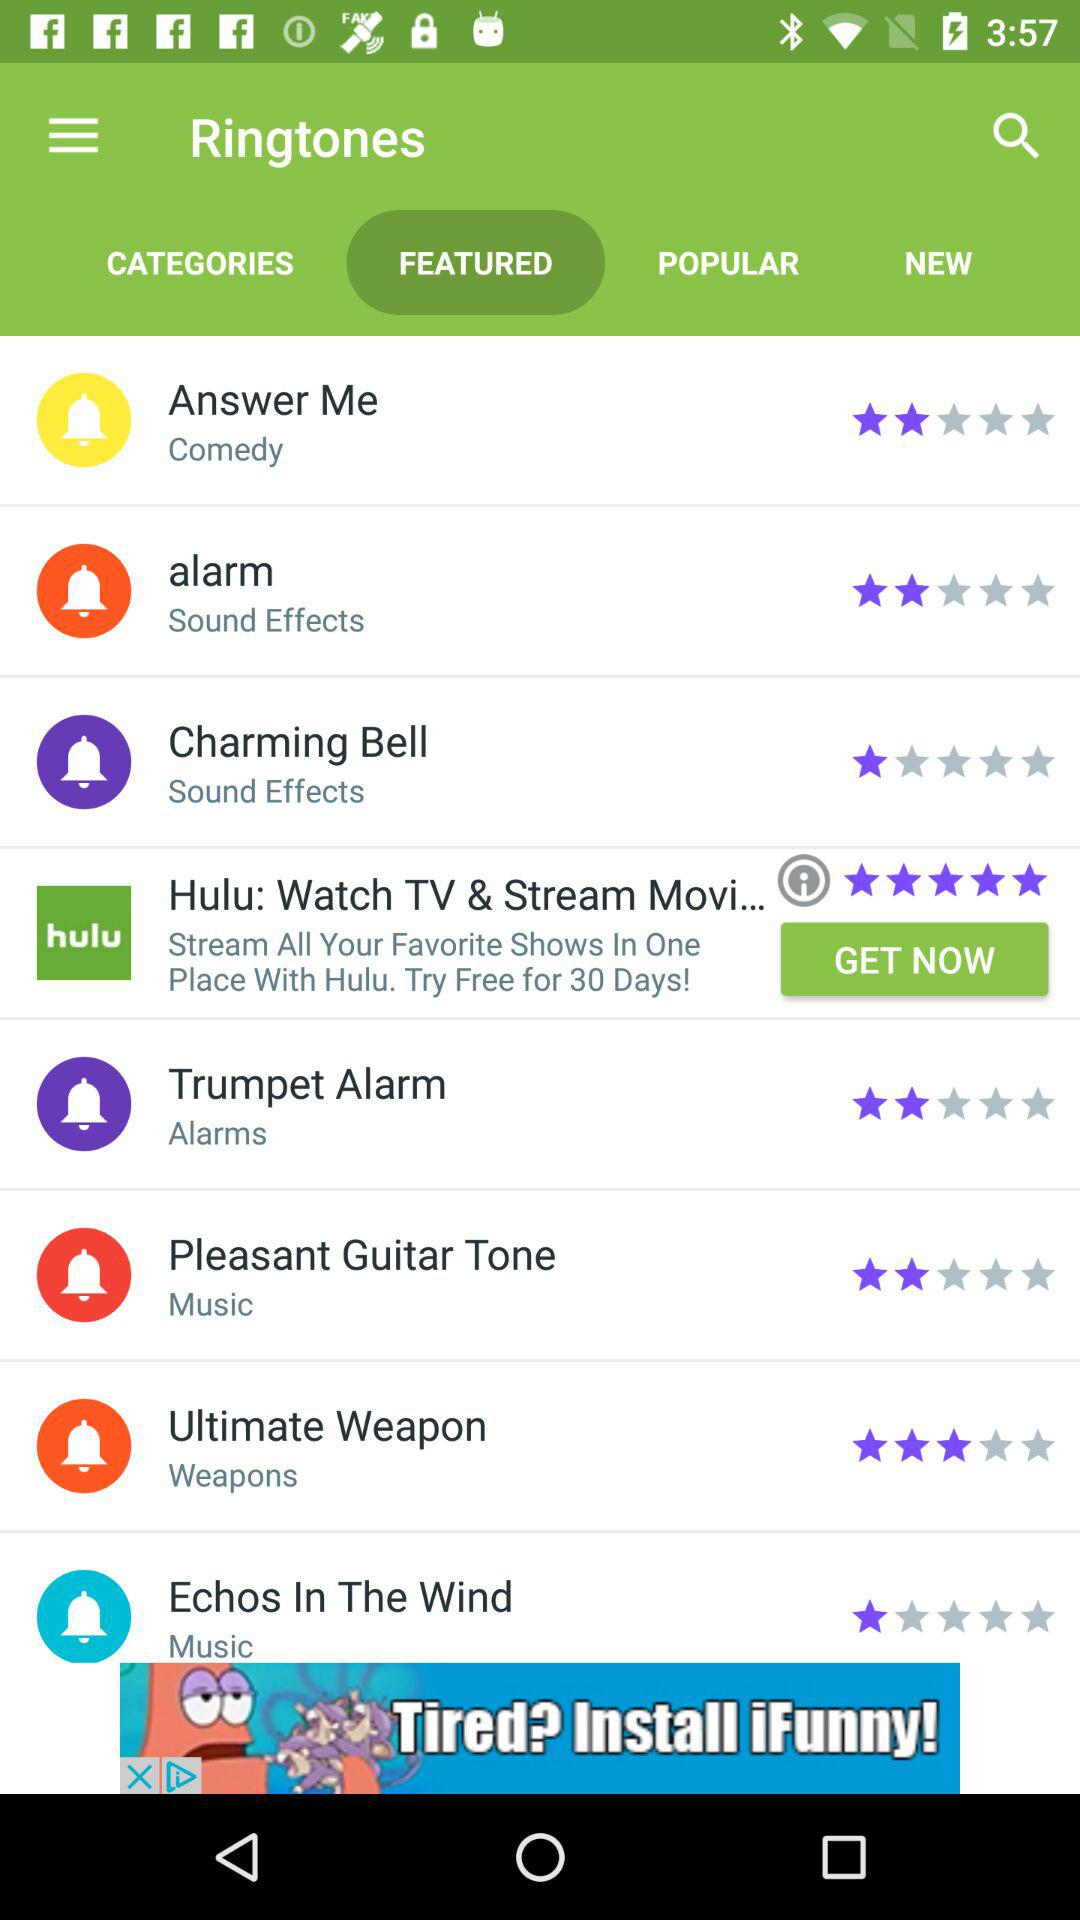Which ringtone is rated three stars? The ringtone rated three stars is "Ultimate Weapon". 